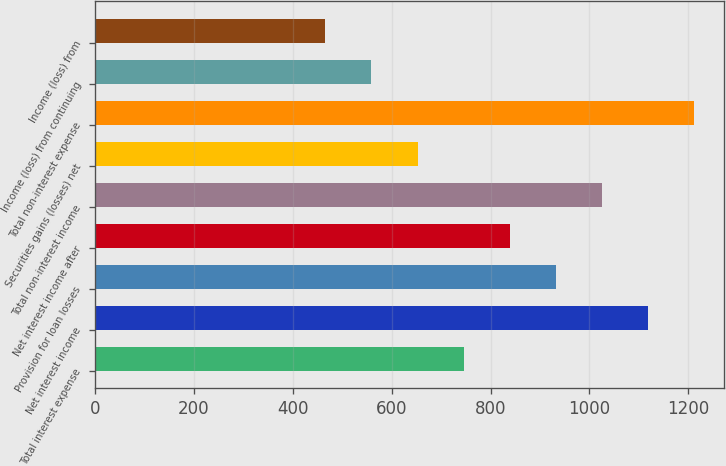Convert chart. <chart><loc_0><loc_0><loc_500><loc_500><bar_chart><fcel>Total interest expense<fcel>Net interest income<fcel>Provision for loan losses<fcel>Net interest income after<fcel>Total non-interest income<fcel>Securities gains (losses) net<fcel>Total non-interest expense<fcel>Income (loss) from continuing<fcel>Income (loss) from<nl><fcel>745.61<fcel>1118.41<fcel>932.01<fcel>838.81<fcel>1025.21<fcel>652.41<fcel>1211.61<fcel>559.21<fcel>466.01<nl></chart> 